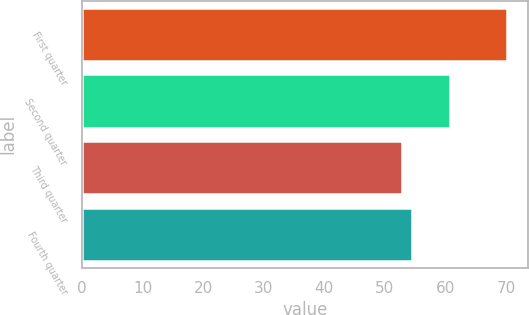Convert chart. <chart><loc_0><loc_0><loc_500><loc_500><bar_chart><fcel>First quarter<fcel>Second quarter<fcel>Third quarter<fcel>Fourth quarter<nl><fcel>70.13<fcel>60.7<fcel>52.81<fcel>54.54<nl></chart> 